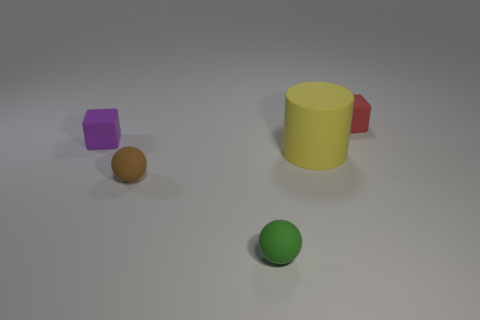Add 3 red cubes. How many objects exist? 8 Subtract all balls. How many objects are left? 3 Subtract all balls. Subtract all green balls. How many objects are left? 2 Add 4 green balls. How many green balls are left? 5 Add 1 tiny cubes. How many tiny cubes exist? 3 Subtract 0 gray balls. How many objects are left? 5 